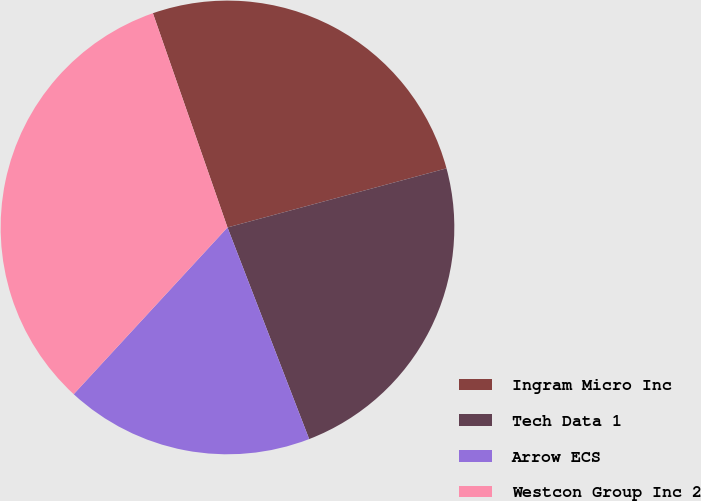Convert chart. <chart><loc_0><loc_0><loc_500><loc_500><pie_chart><fcel>Ingram Micro Inc<fcel>Tech Data 1<fcel>Arrow ECS<fcel>Westcon Group Inc 2<nl><fcel>26.14%<fcel>23.33%<fcel>17.72%<fcel>32.81%<nl></chart> 